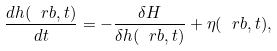<formula> <loc_0><loc_0><loc_500><loc_500>\frac { d h ( \ r b , t ) } { d t } = - \frac { \delta H } { \delta h ( \ r b , t ) } + \eta ( \ r b , t ) ,</formula> 